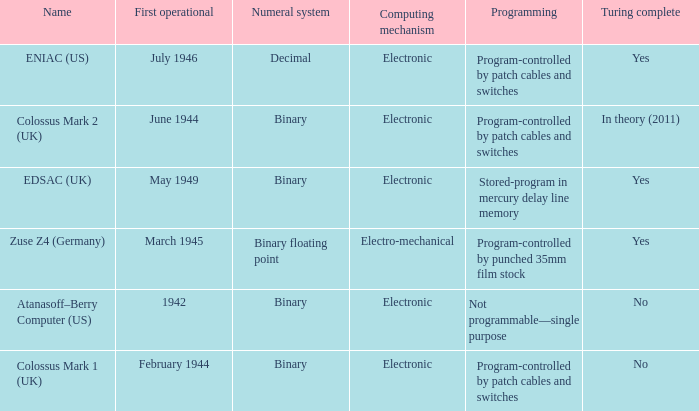What's the first operational with programming being not programmable—single purpose 1942.0. 